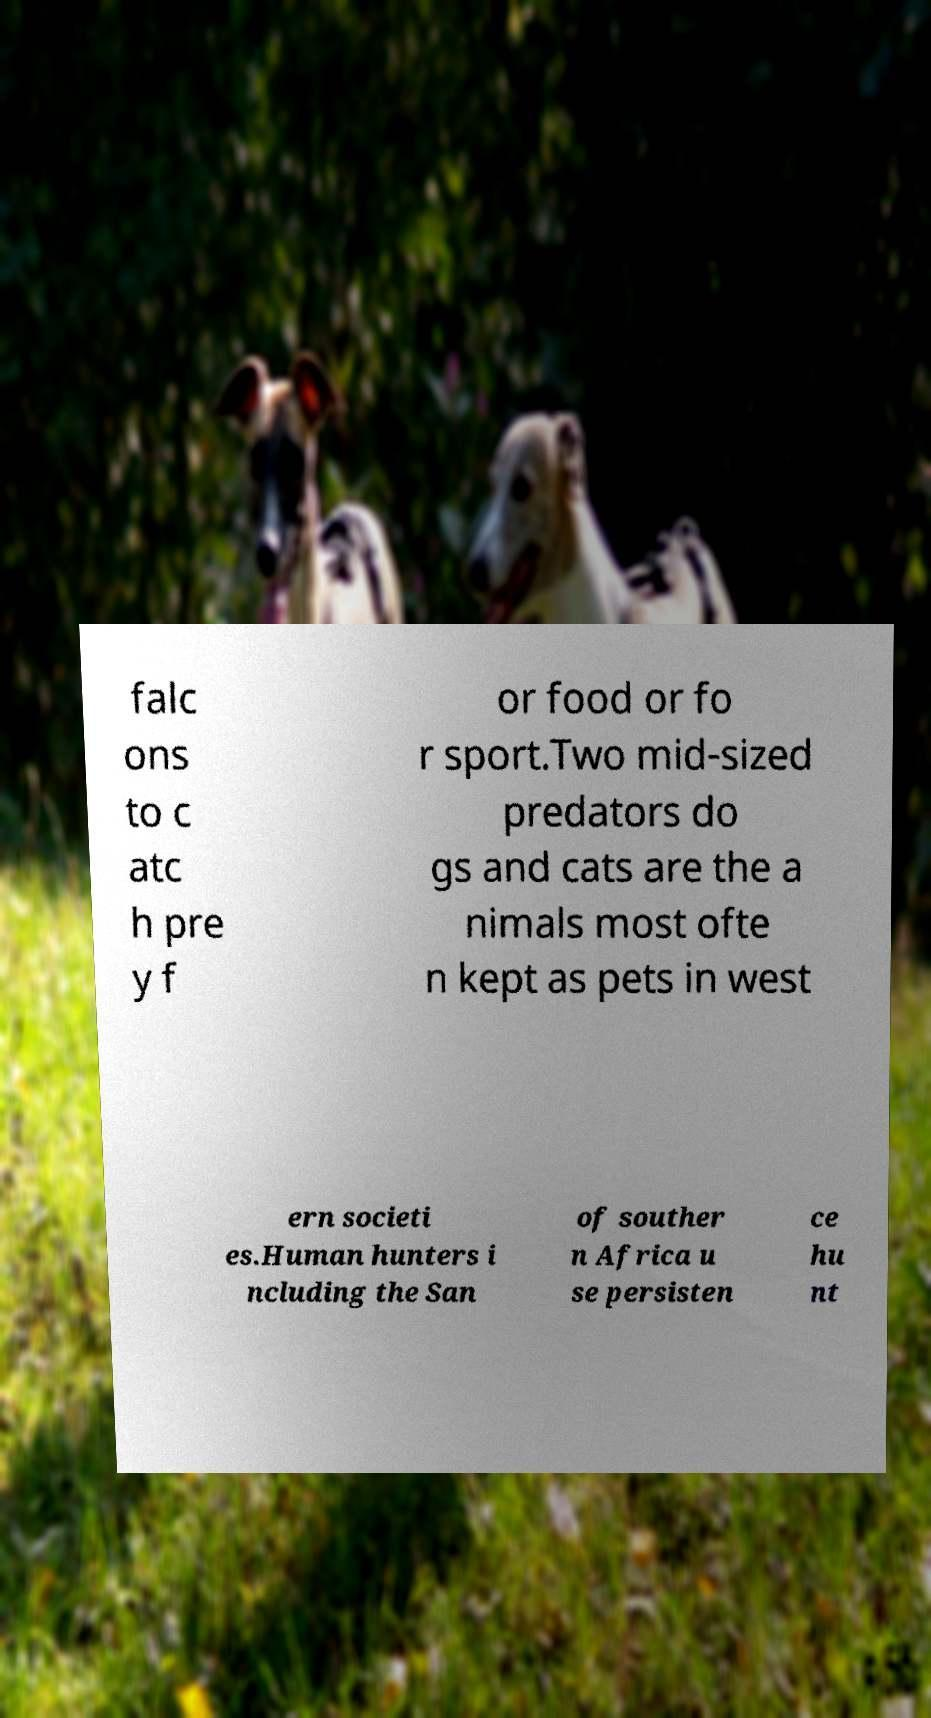There's text embedded in this image that I need extracted. Can you transcribe it verbatim? falc ons to c atc h pre y f or food or fo r sport.Two mid-sized predators do gs and cats are the a nimals most ofte n kept as pets in west ern societi es.Human hunters i ncluding the San of souther n Africa u se persisten ce hu nt 